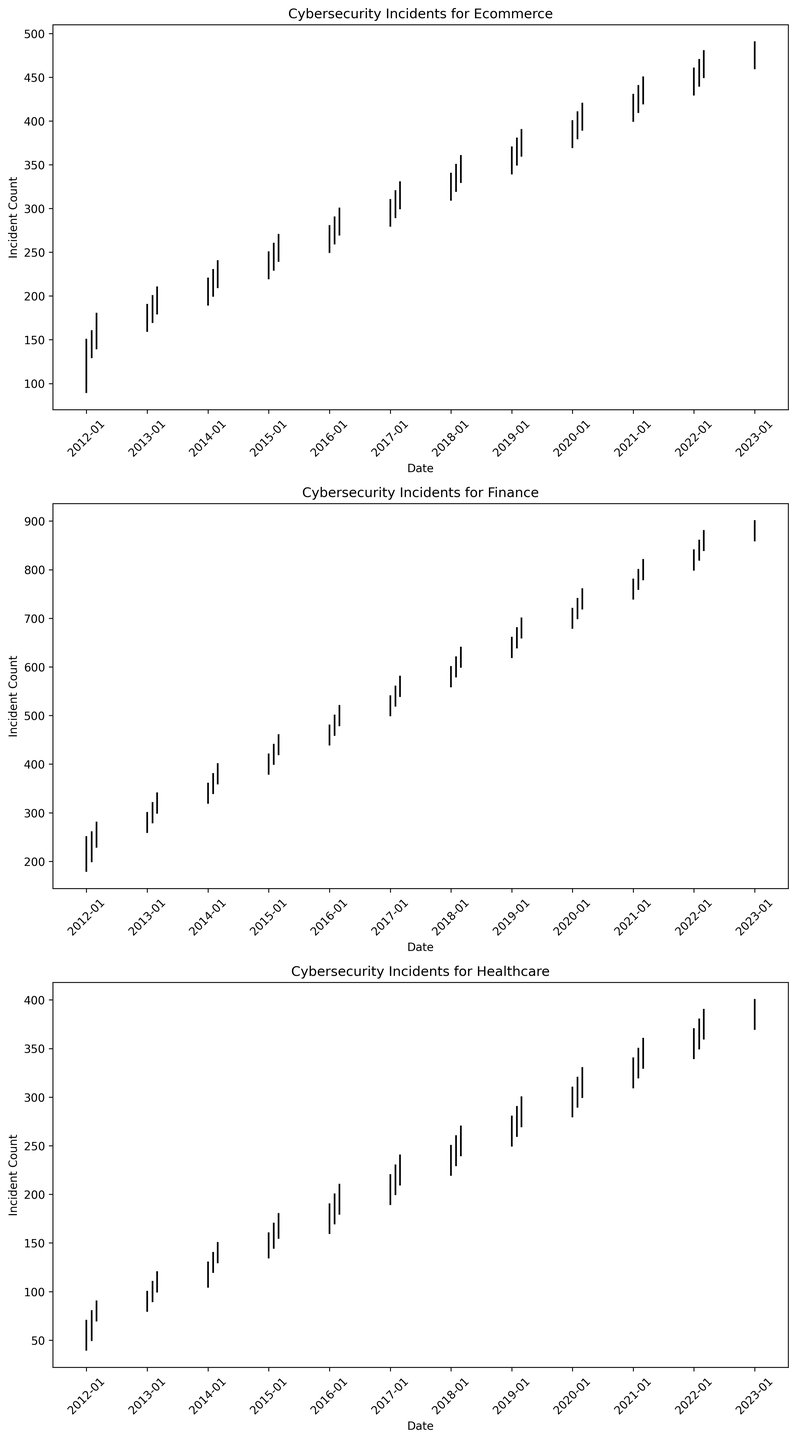Which industry experienced the most significant increase in incidents from 2012 to 2023? To find the most significant increase, compare the incident counts from the beginning of 2012 to the beginning of 2023 for each industry. The Finance industry saw the most substantial increase, as its incidents grew from 220 to 890.
Answer: Finance Did the average cyber incident count for the Healthcare industry follow an increasing trend over the years? Calculate the average count for yearly data points (starting month of each year). Observe that the average count increases from one average to the next consistently. For Healthcare, the trend is upward from 60 in 2012 to 390 in 2023.
Answer: Yes What was the maximum incident count within each industry, and when did it occur? For each industry, locate the highest value in the 'High' column and the corresponding date. Ecommerce: 490 (2023-01), Finance: 900 (2023-01), Healthcare: 400 (2023-01).
Answer: Ecommerce: 490 (2023-01), Finance: 900 (2023-01), Healthcare: 400 (2023-01) Which industry had the highest volatility in incidents during the observed period? Volatility can be interpreted as the range between high and low values. Calculate the range (High - Low) for each industry over the entire period. The Finance industry shows the highest difference, with a range from 180 to 900.
Answer: Finance How did the Ecommerce incident count change between March 2012 and January 2013? Note the 'Close' value for Ecommerce in March 2012 (170) and in January 2013 (180). Compute the difference: 180 - 170 = 10.
Answer: Increased by 10 In which year did the Finance industry see the lowest number of incidents, and what value was it? Identify the lowest 'Low' value for the Finance industry and check the corresponding date. The lowest was 180 in January 2012.
Answer: 2012, 180 Compare the incident trends for Ecommerce and Healthcare industries in 2020. Which had a higher growth rate throughout the year? Examine the 'Open' and 'Close' values for both industries in 2020. Compute the growth rate for each: Ecommerce (410-380)/380 = 0.079, Healthcare (320-290)/290 = 0.103. Healthcare shows a higher growth rate.
Answer: Healthcare What is the visual indicator that shows an increase in incidents for a month in the candlestick chart? When the closing value is higher than the opening value, the candlestick is green, indicating an increase.
Answer: Green candlestick 